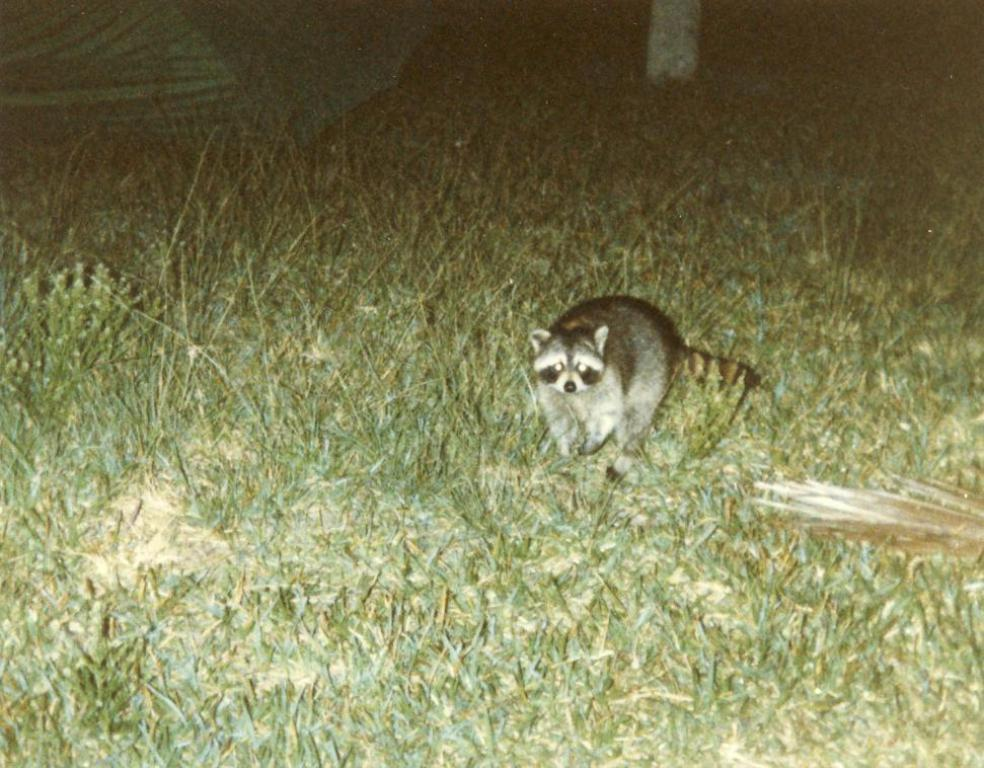What type of surface is visible in the image? There is a grass surface in the image. Is there any living creature on the grass surface? Yes, there is an animal on the grass surface. What else can be seen in the image besides the grass surface and the animal? There is a green tent visible in the image. What type of face can be seen on the animal in the image? There is no face visible on the animal in the image, as it is not a human or an animal with a distinguishable face. 